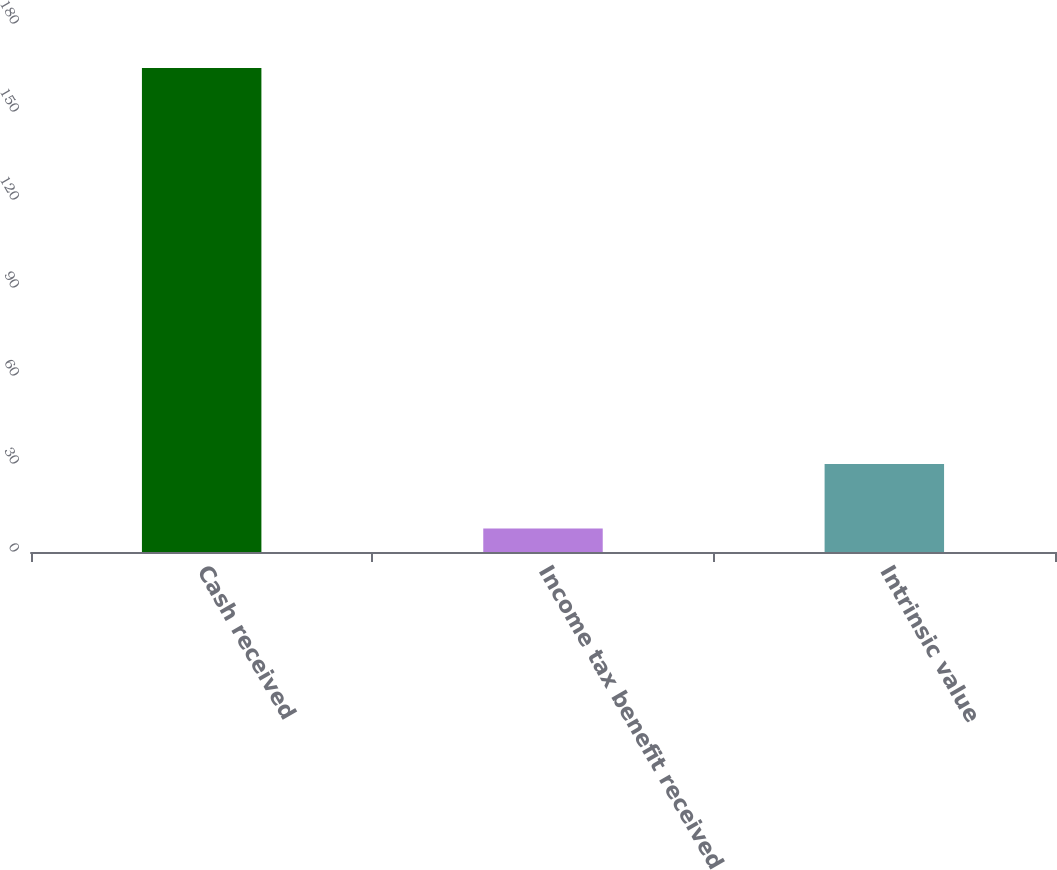<chart> <loc_0><loc_0><loc_500><loc_500><bar_chart><fcel>Cash received<fcel>Income tax benefit received<fcel>Intrinsic value<nl><fcel>165<fcel>8<fcel>30<nl></chart> 